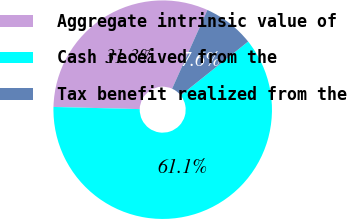Convert chart to OTSL. <chart><loc_0><loc_0><loc_500><loc_500><pie_chart><fcel>Aggregate intrinsic value of<fcel>Cash received from the<fcel>Tax benefit realized from the<nl><fcel>31.31%<fcel>61.11%<fcel>7.58%<nl></chart> 